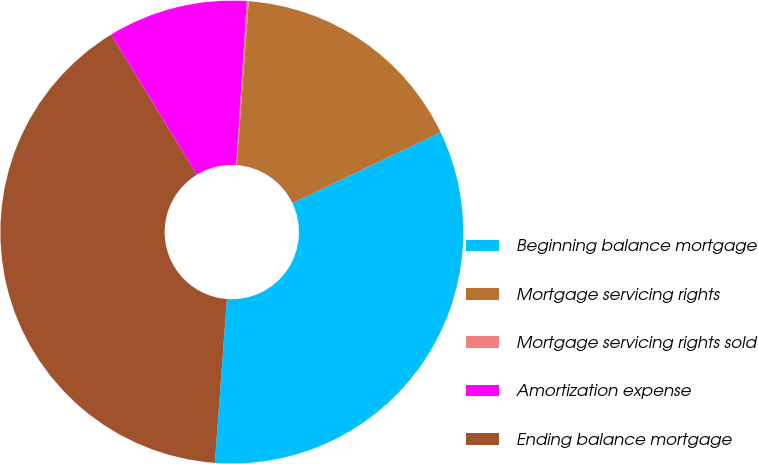Convert chart to OTSL. <chart><loc_0><loc_0><loc_500><loc_500><pie_chart><fcel>Beginning balance mortgage<fcel>Mortgage servicing rights<fcel>Mortgage servicing rights sold<fcel>Amortization expense<fcel>Ending balance mortgage<nl><fcel>33.26%<fcel>16.74%<fcel>0.13%<fcel>9.77%<fcel>40.1%<nl></chart> 